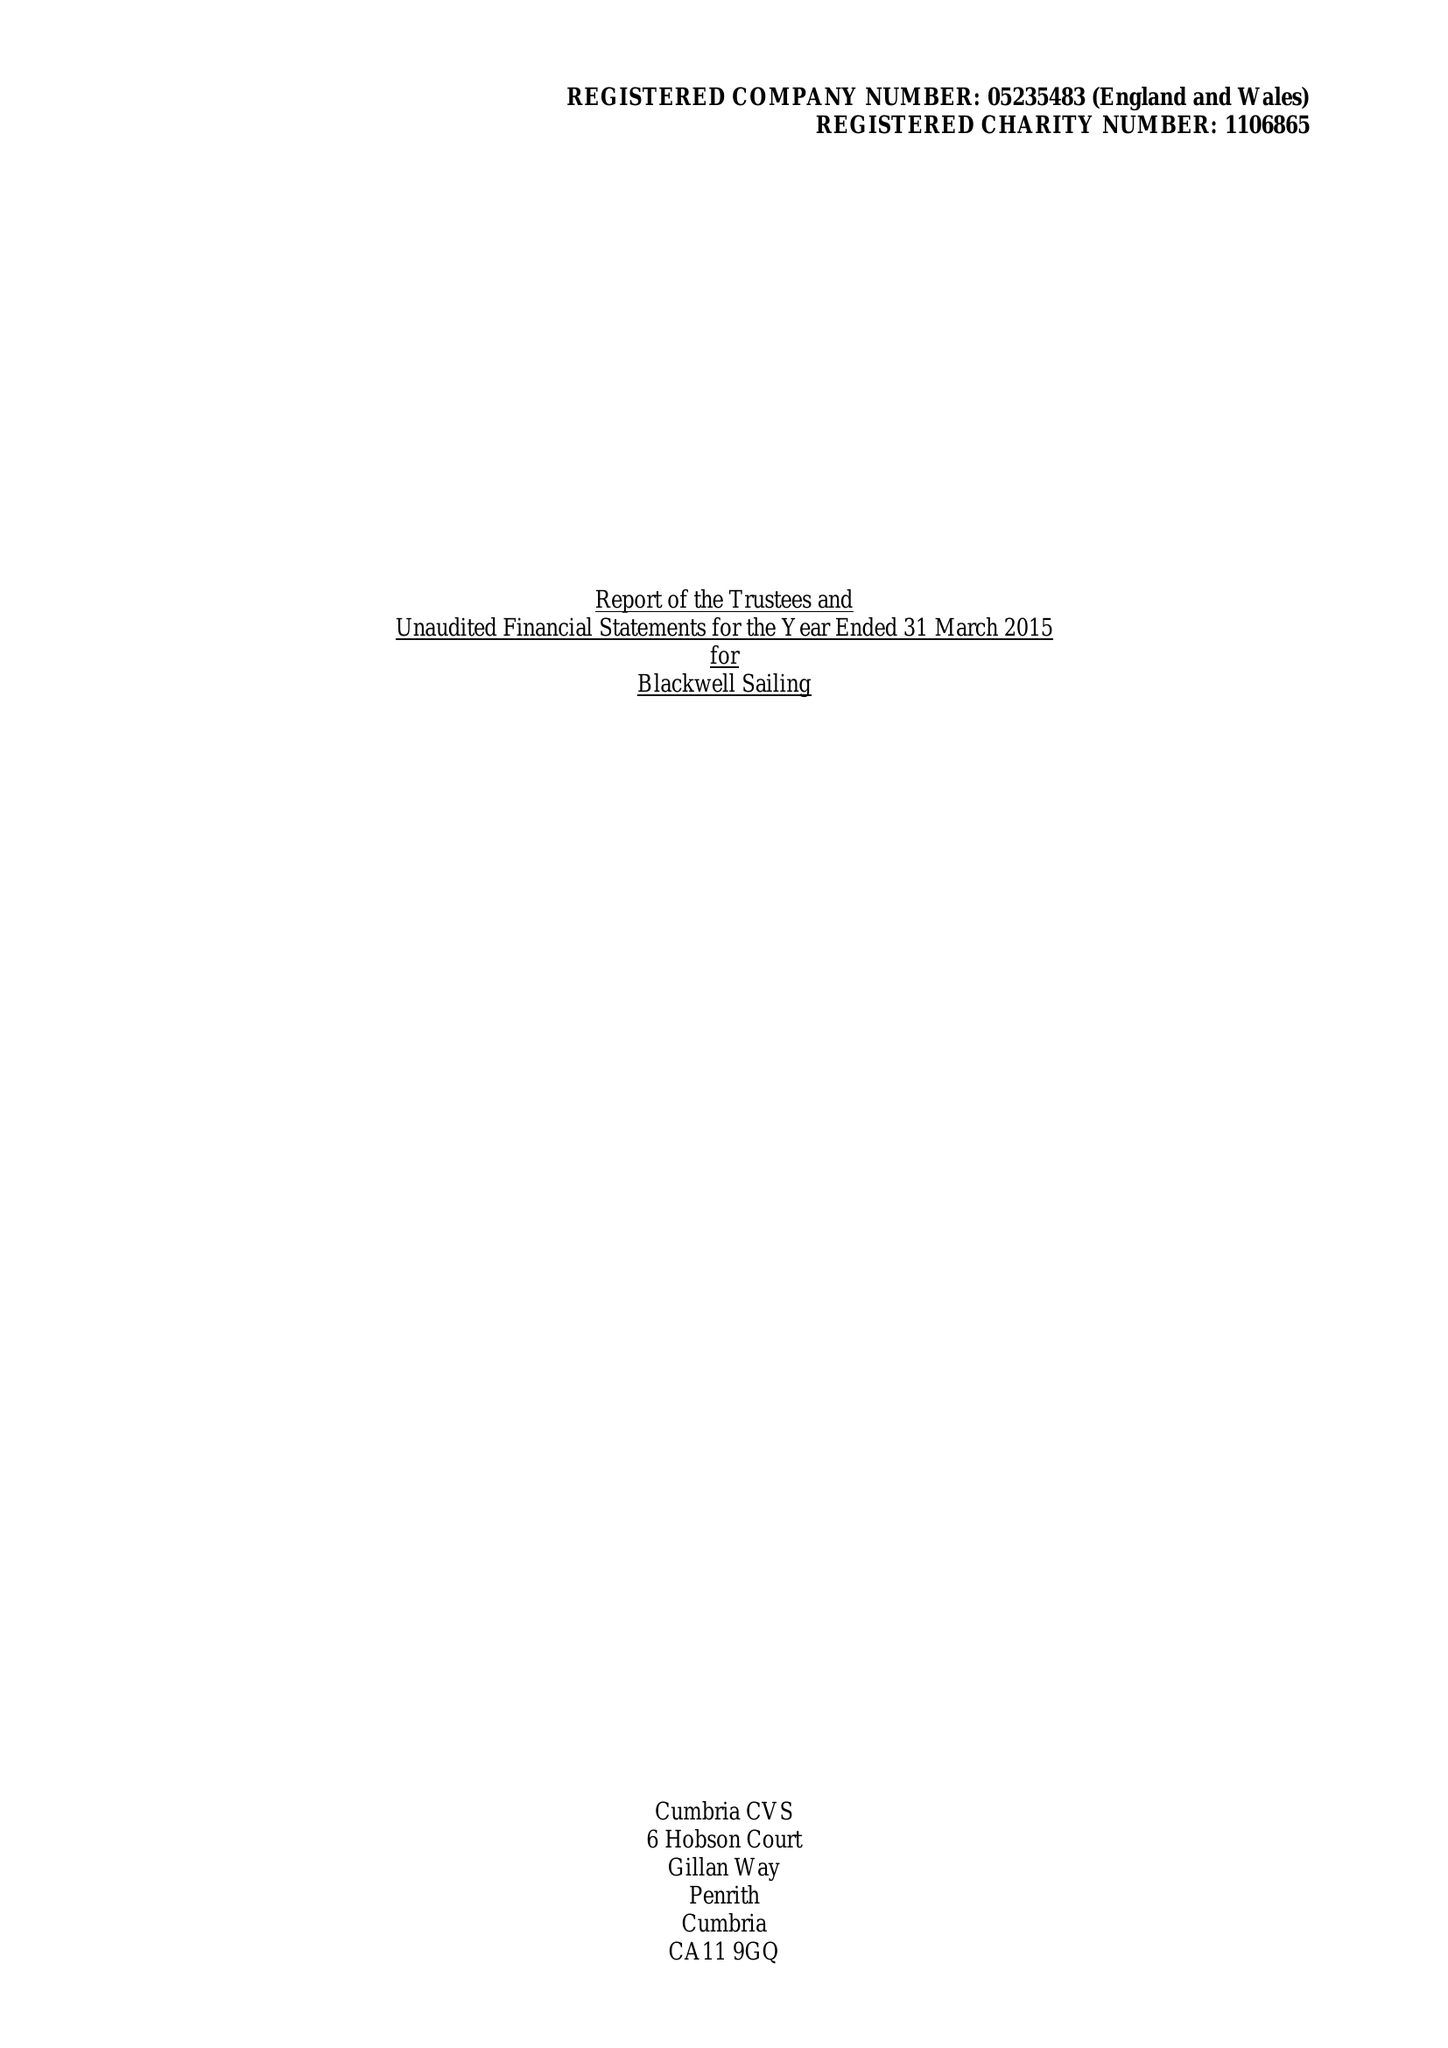What is the value for the income_annually_in_british_pounds?
Answer the question using a single word or phrase. 50231.00 